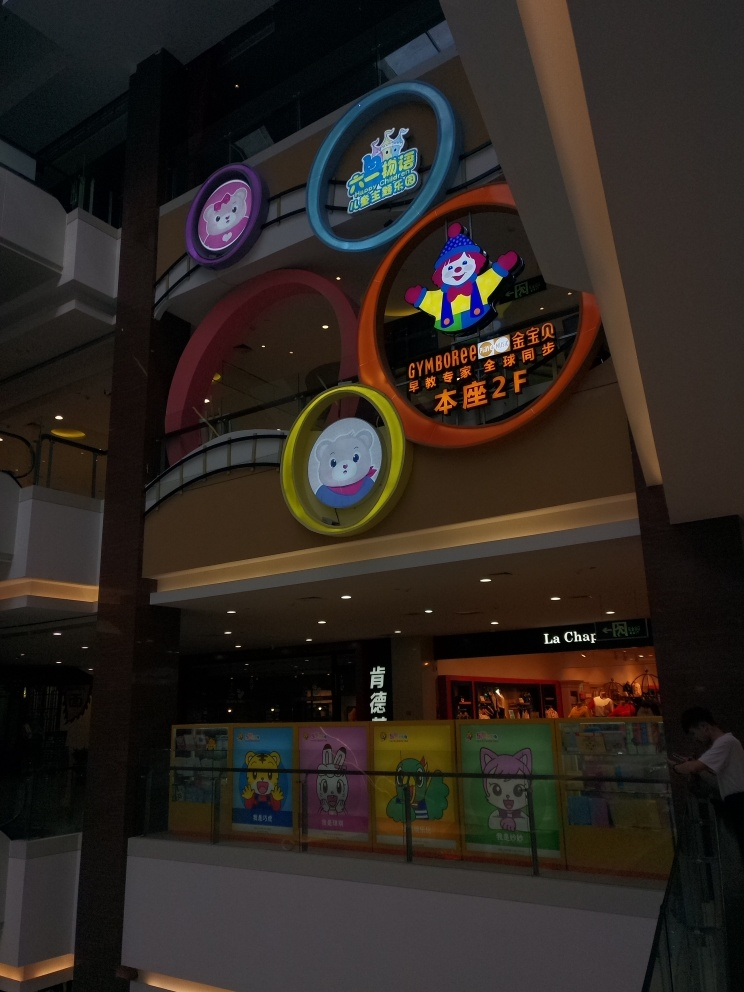Which elements of this image suggest that it might be a place designed for children? The image features vibrant colors and cartoon character imagery, which are commonly associated with children's entertainment and learning environments. The presence of store names and play areas like 'GYMBOREE' point to services and products aimed at a younger audience. Additionally, the playful clown figure in the signage further reinforces the child-friendly theme. 